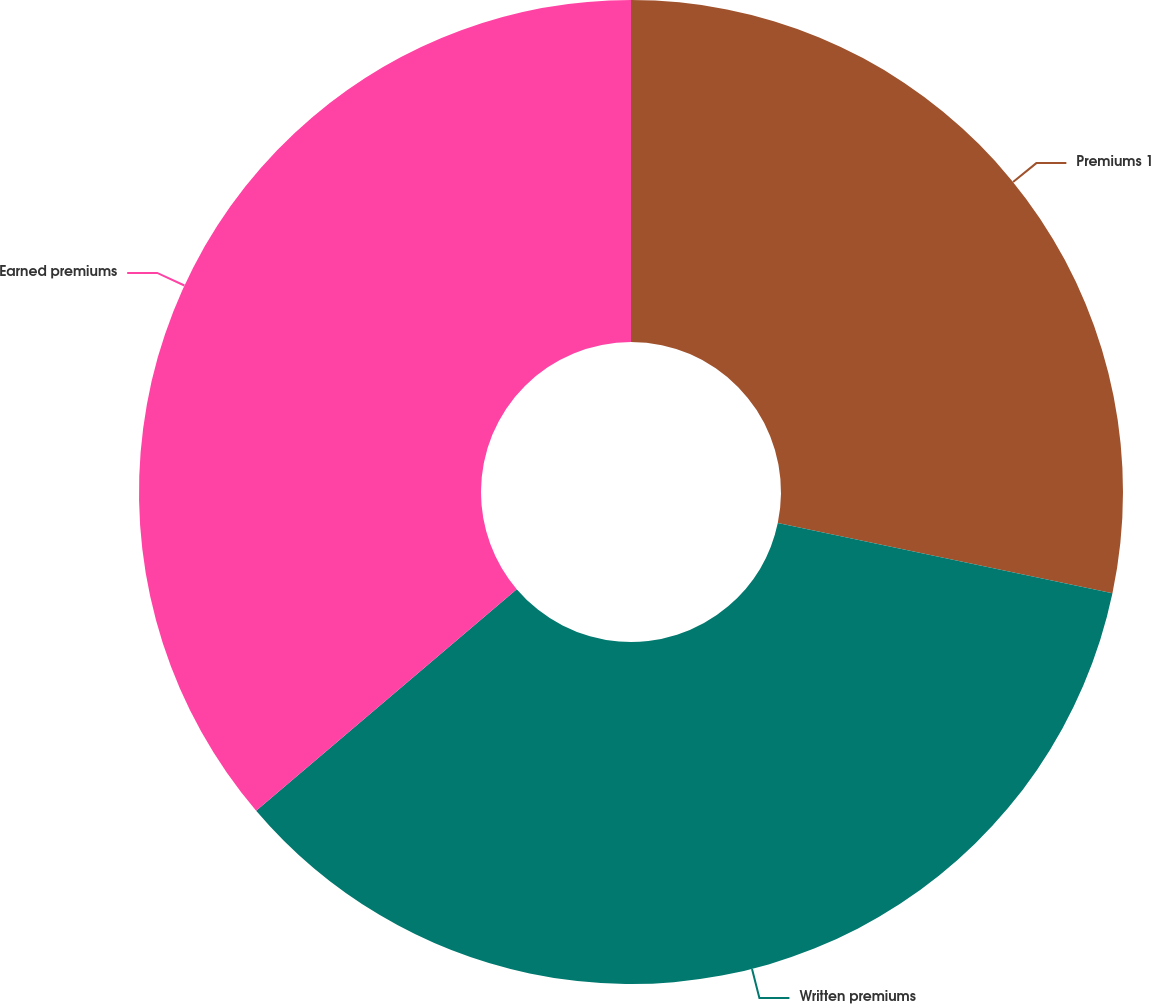<chart> <loc_0><loc_0><loc_500><loc_500><pie_chart><fcel>Premiums 1<fcel>Written premiums<fcel>Earned premiums<nl><fcel>28.3%<fcel>35.48%<fcel>36.21%<nl></chart> 